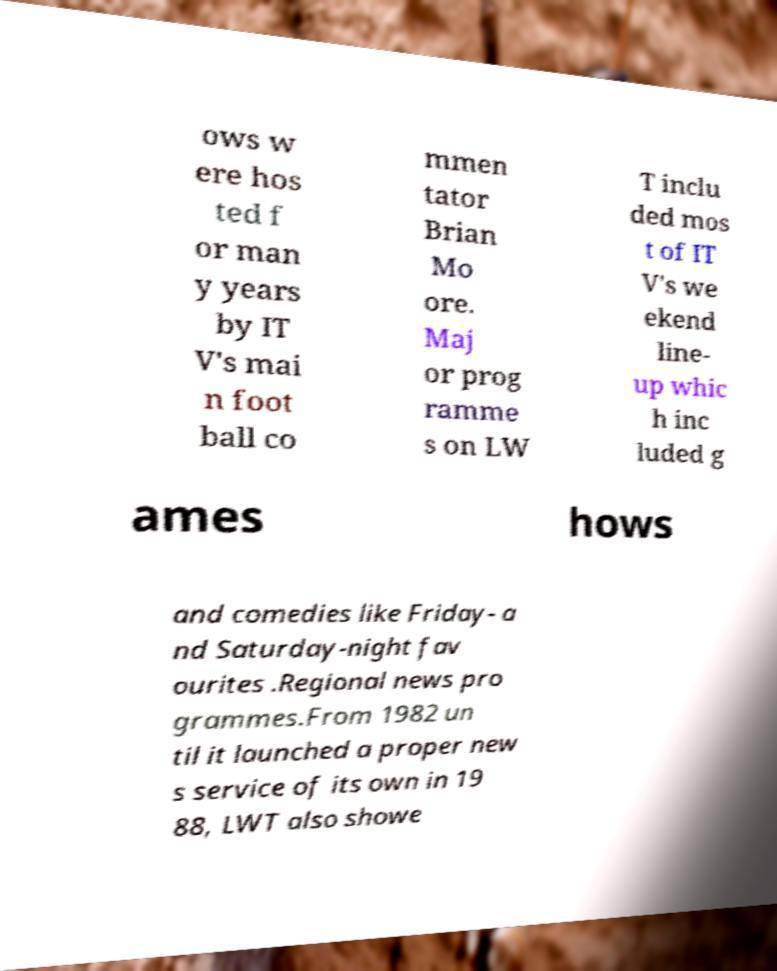Can you read and provide the text displayed in the image?This photo seems to have some interesting text. Can you extract and type it out for me? ows w ere hos ted f or man y years by IT V's mai n foot ball co mmen tator Brian Mo ore. Maj or prog ramme s on LW T inclu ded mos t of IT V's we ekend line- up whic h inc luded g ames hows and comedies like Friday- a nd Saturday-night fav ourites .Regional news pro grammes.From 1982 un til it launched a proper new s service of its own in 19 88, LWT also showe 